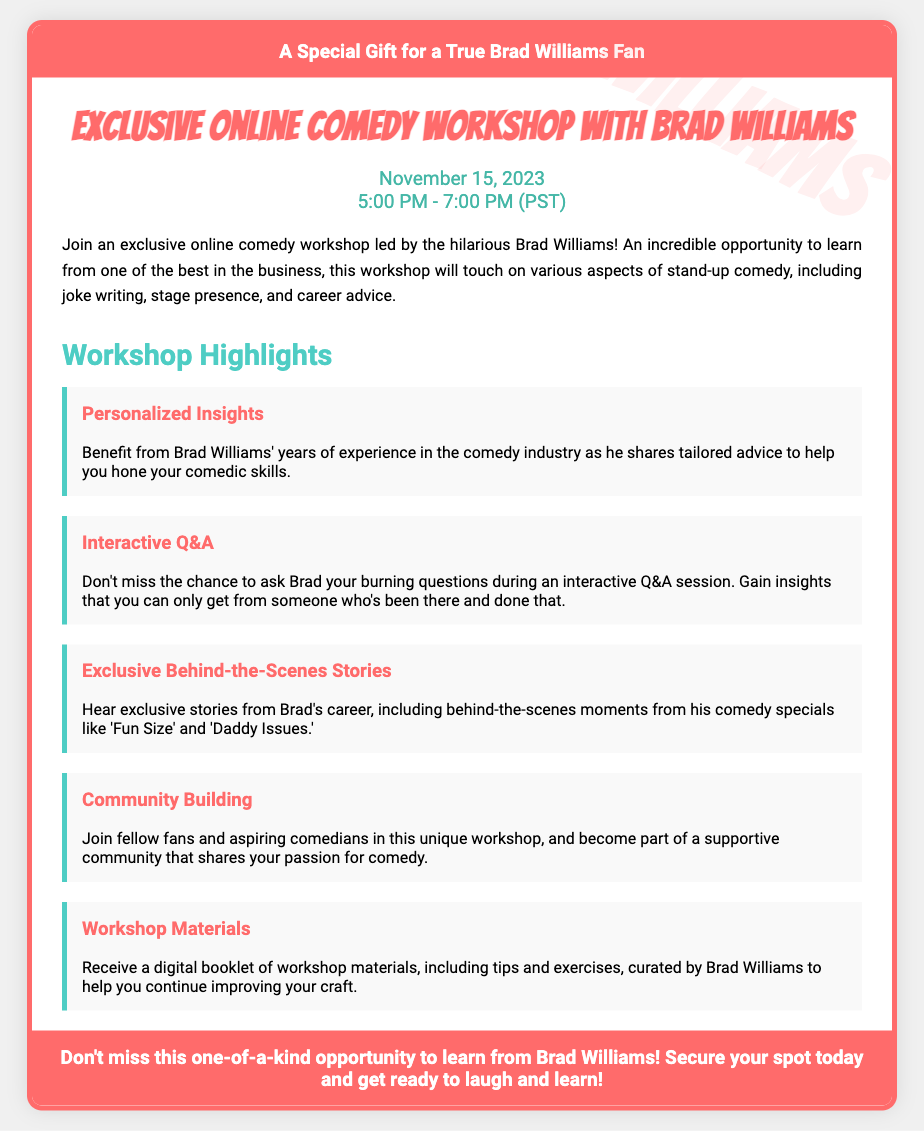What is the title of the workshop? The title of the workshop is explicitly mentioned in the document heading as "Exclusive Online Comedy Workshop with Brad Williams."
Answer: Exclusive Online Comedy Workshop with Brad Williams When is the workshop scheduled? The workshop date and time are provided in the date-time section: "November 15, 2023, 5:00 PM - 7:00 PM (PST)."
Answer: November 15, 2023 What type of advice will Brad Williams provide? The document mentions that Brad will share "personalized insights" tailored to help improve comedic skills.
Answer: Personalized insights What will participants receive as workshop materials? The document states that participants will receive "a digital booklet of workshop materials."
Answer: Digital booklet What unique feature does the workshop offer to attendees? An opportunity for an "Interactive Q&A" session with Brad is highlighted as a unique feature of the workshop.
Answer: Interactive Q&A What does the footer emphasize about this opportunity? The footer states, "Don't miss this one-of-a-kind opportunity to learn from Brad Williams!" which emphasizes the uniqueness of the opportunity.
Answer: One-of-a-kind opportunity Which two comedy specials are mentioned in relation to Brad's stories? The document specifically references "Fun Size" and "Daddy Issues" as the comedy specials for behind-the-scenes stories.
Answer: Fun Size and Daddy Issues 